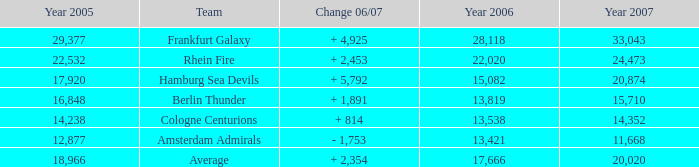What is the sum of Year 2007(s), when the Year 2005 is greater than 29,377? None. 